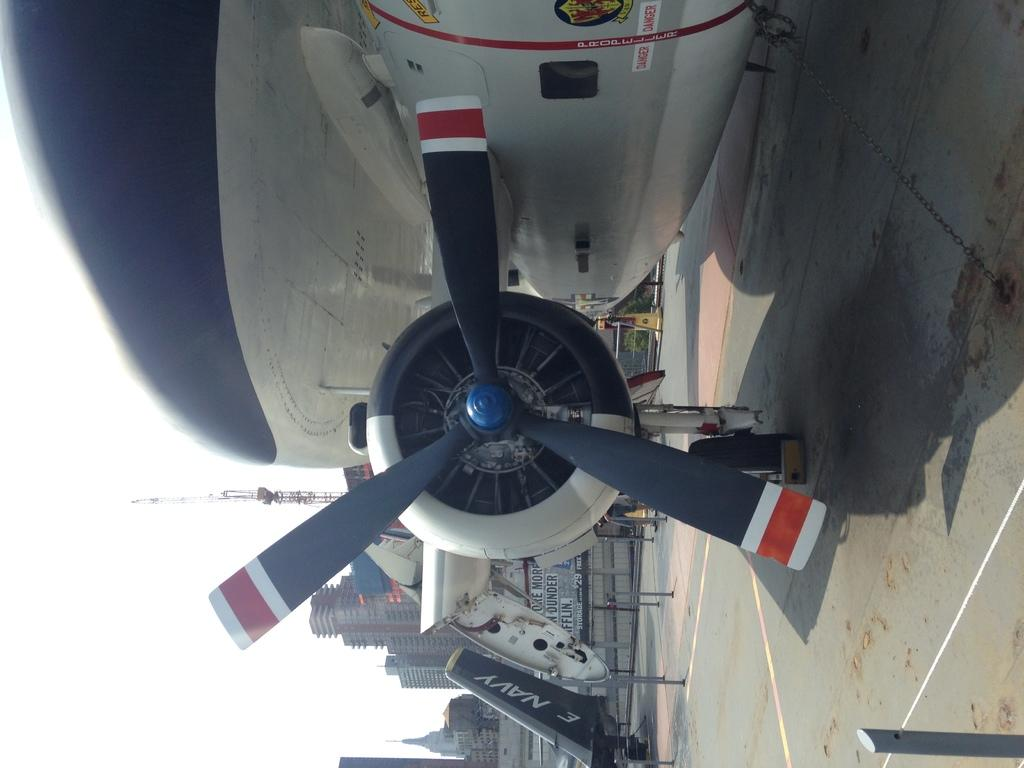Provide a one-sentence caption for the provided image. the propeller of a navy plane leaves a large shadow. 